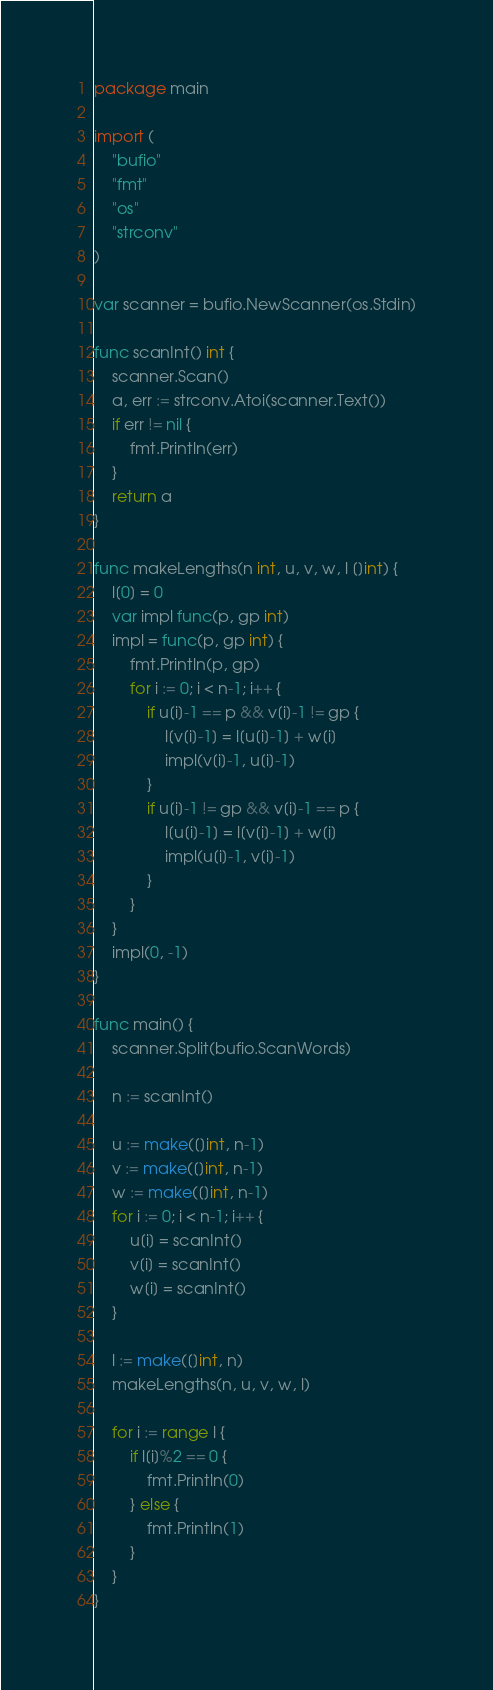Convert code to text. <code><loc_0><loc_0><loc_500><loc_500><_Go_>package main

import (
	"bufio"
	"fmt"
	"os"
	"strconv"
)

var scanner = bufio.NewScanner(os.Stdin)

func scanInt() int {
	scanner.Scan()
	a, err := strconv.Atoi(scanner.Text())
	if err != nil {
		fmt.Println(err)
	}
	return a
}

func makeLengths(n int, u, v, w, l []int) {
	l[0] = 0
	var impl func(p, gp int)
	impl = func(p, gp int) {
		fmt.Println(p, gp)
		for i := 0; i < n-1; i++ {
			if u[i]-1 == p && v[i]-1 != gp {
				l[v[i]-1] = l[u[i]-1] + w[i]
				impl(v[i]-1, u[i]-1)
			}
			if u[i]-1 != gp && v[i]-1 == p {
				l[u[i]-1] = l[v[i]-1] + w[i]
				impl(u[i]-1, v[i]-1)
			}
		}
	}
	impl(0, -1)
}

func main() {
	scanner.Split(bufio.ScanWords)

	n := scanInt()

	u := make([]int, n-1)
	v := make([]int, n-1)
	w := make([]int, n-1)
	for i := 0; i < n-1; i++ {
		u[i] = scanInt()
		v[i] = scanInt()
		w[i] = scanInt()
	}

	l := make([]int, n)
	makeLengths(n, u, v, w, l)

	for i := range l {
		if l[i]%2 == 0 {
			fmt.Println(0)
		} else {
			fmt.Println(1)
		}
	}
}
</code> 